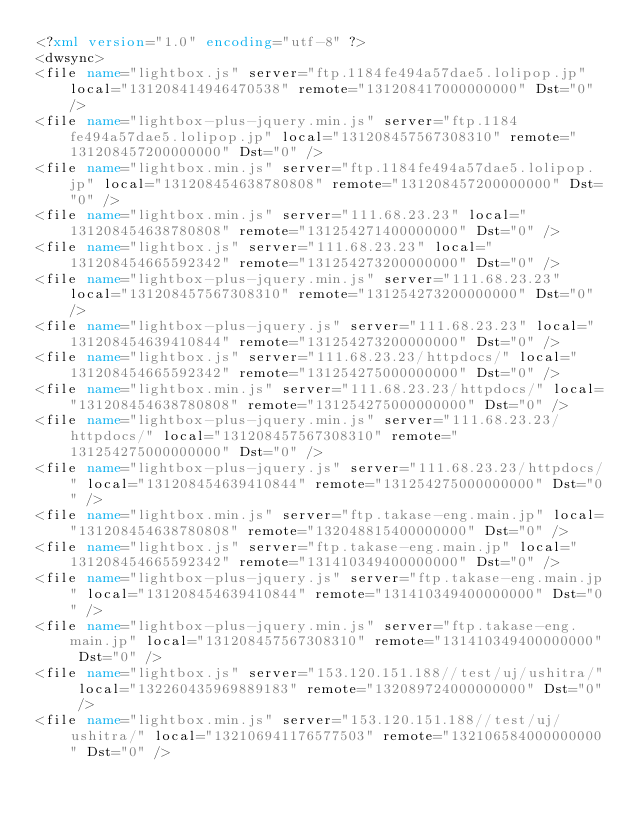Convert code to text. <code><loc_0><loc_0><loc_500><loc_500><_XML_><?xml version="1.0" encoding="utf-8" ?>
<dwsync>
<file name="lightbox.js" server="ftp.1184fe494a57dae5.lolipop.jp" local="131208414946470538" remote="131208417000000000" Dst="0" />
<file name="lightbox-plus-jquery.min.js" server="ftp.1184fe494a57dae5.lolipop.jp" local="131208457567308310" remote="131208457200000000" Dst="0" />
<file name="lightbox.min.js" server="ftp.1184fe494a57dae5.lolipop.jp" local="131208454638780808" remote="131208457200000000" Dst="0" />
<file name="lightbox.min.js" server="111.68.23.23" local="131208454638780808" remote="131254271400000000" Dst="0" />
<file name="lightbox.js" server="111.68.23.23" local="131208454665592342" remote="131254273200000000" Dst="0" />
<file name="lightbox-plus-jquery.min.js" server="111.68.23.23" local="131208457567308310" remote="131254273200000000" Dst="0" />
<file name="lightbox-plus-jquery.js" server="111.68.23.23" local="131208454639410844" remote="131254273200000000" Dst="0" />
<file name="lightbox.js" server="111.68.23.23/httpdocs/" local="131208454665592342" remote="131254275000000000" Dst="0" />
<file name="lightbox.min.js" server="111.68.23.23/httpdocs/" local="131208454638780808" remote="131254275000000000" Dst="0" />
<file name="lightbox-plus-jquery.min.js" server="111.68.23.23/httpdocs/" local="131208457567308310" remote="131254275000000000" Dst="0" />
<file name="lightbox-plus-jquery.js" server="111.68.23.23/httpdocs/" local="131208454639410844" remote="131254275000000000" Dst="0" />
<file name="lightbox.min.js" server="ftp.takase-eng.main.jp" local="131208454638780808" remote="132048815400000000" Dst="0" />
<file name="lightbox.js" server="ftp.takase-eng.main.jp" local="131208454665592342" remote="131410349400000000" Dst="0" />
<file name="lightbox-plus-jquery.js" server="ftp.takase-eng.main.jp" local="131208454639410844" remote="131410349400000000" Dst="0" />
<file name="lightbox-plus-jquery.min.js" server="ftp.takase-eng.main.jp" local="131208457567308310" remote="131410349400000000" Dst="0" />
<file name="lightbox.js" server="153.120.151.188//test/uj/ushitra/" local="132260435969889183" remote="132089724000000000" Dst="0" />
<file name="lightbox.min.js" server="153.120.151.188//test/uj/ushitra/" local="132106941176577503" remote="132106584000000000" Dst="0" /></code> 